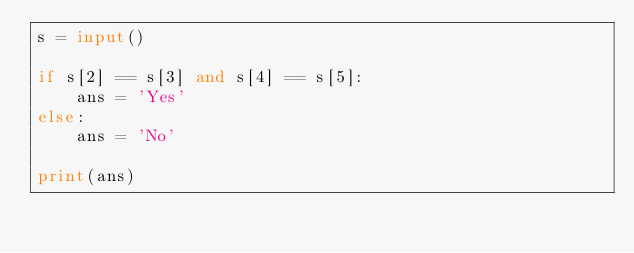Convert code to text. <code><loc_0><loc_0><loc_500><loc_500><_Python_>s = input()

if s[2] == s[3] and s[4] == s[5]:
    ans = 'Yes'
else:
    ans = 'No'

print(ans)</code> 